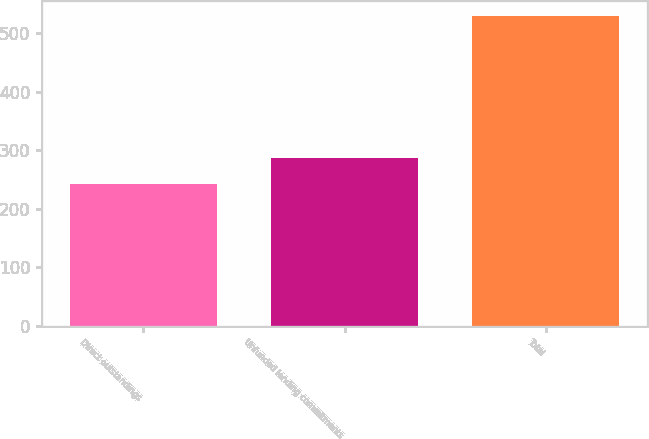Convert chart. <chart><loc_0><loc_0><loc_500><loc_500><bar_chart><fcel>Direct outstandings<fcel>Unfunded lending commitments<fcel>Total<nl><fcel>242<fcel>287<fcel>529<nl></chart> 